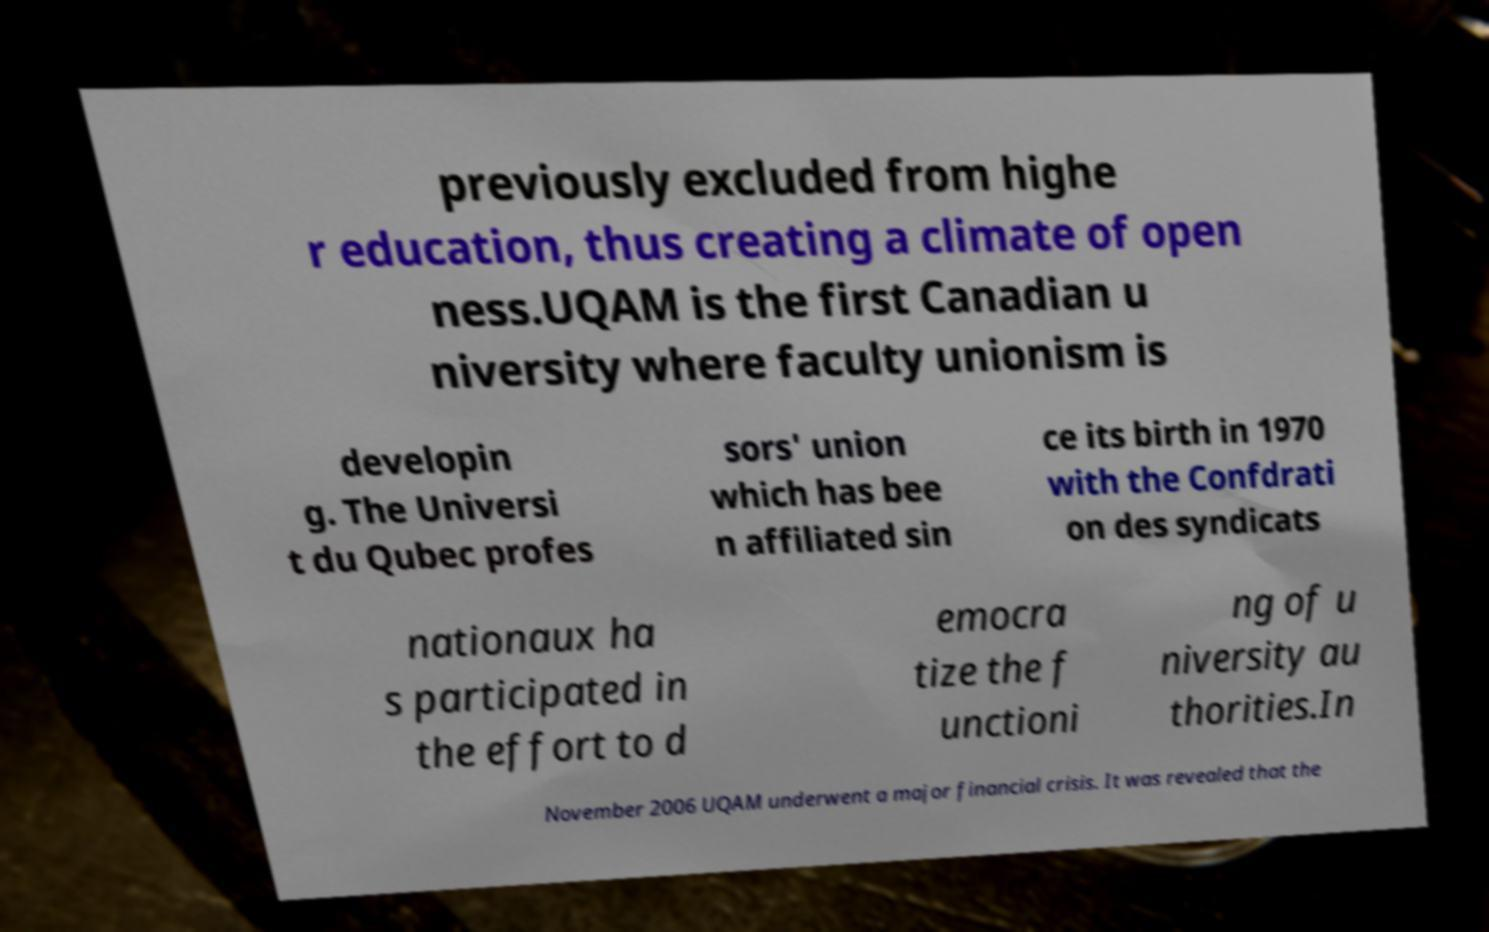Please read and relay the text visible in this image. What does it say? previously excluded from highe r education, thus creating a climate of open ness.UQAM is the first Canadian u niversity where faculty unionism is developin g. The Universi t du Qubec profes sors' union which has bee n affiliated sin ce its birth in 1970 with the Confdrati on des syndicats nationaux ha s participated in the effort to d emocra tize the f unctioni ng of u niversity au thorities.In November 2006 UQAM underwent a major financial crisis. It was revealed that the 